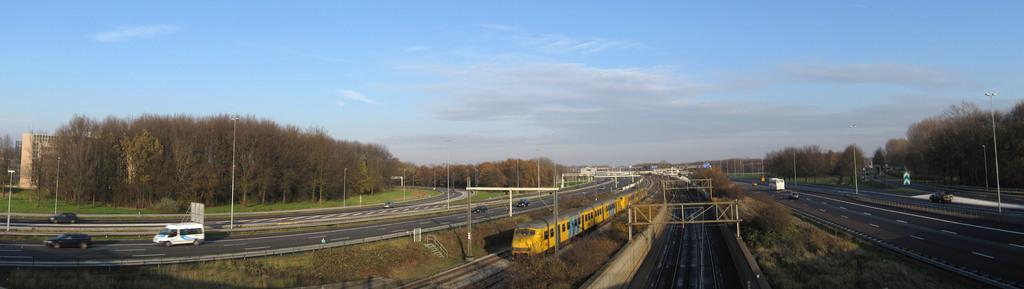Describe this image in one or two sentences. This is an outside view. In the middle of the image there is a train on the railway track and there are few poles. On the right and left side of the image there are few vehicles on the roads. In the background there are many trees and light poles. On the left side there is a building. At the top of the image I can see the sky and clouds. 